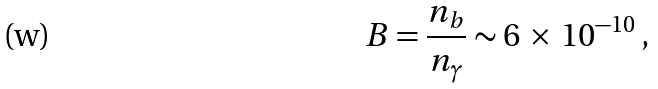<formula> <loc_0><loc_0><loc_500><loc_500>B = \frac { n _ { b } } { n _ { \gamma } } \sim 6 \, \times \, 1 0 ^ { - 1 0 } \, ,</formula> 